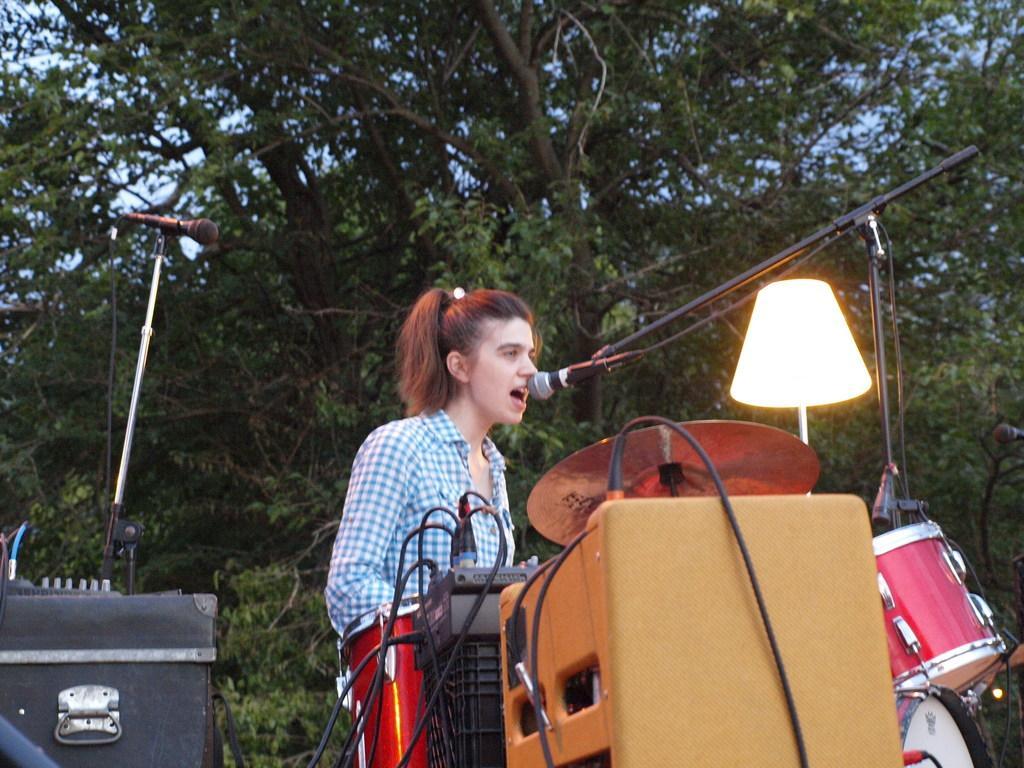Can you describe this image briefly? In the middle of the picture, we see a woman is standing. In front of her, we see a microphone. She is singing the song on the microphone. In front of her, we see the amplifiers and the drums. Beside that, we see a lamp. On the left side, we see a speaker box and a microphone. There are trees in the background. 